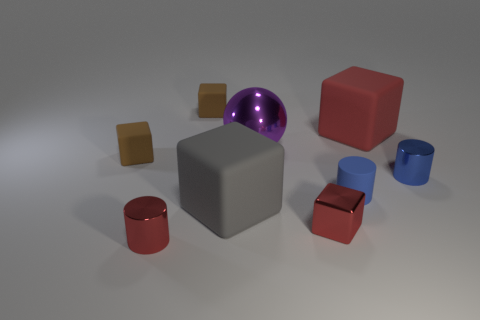How many red things are in front of the big purple thing and behind the tiny red shiny cylinder?
Give a very brief answer. 1. How many objects are either blue cylinders or large rubber cubes left of the matte cylinder?
Give a very brief answer. 3. Are there more purple spheres than small blue cylinders?
Your answer should be very brief. No. What shape is the tiny thing in front of the tiny red cube?
Keep it short and to the point. Cylinder. How many red metal things are the same shape as the blue rubber thing?
Offer a terse response. 1. There is a cube to the left of the tiny shiny object that is left of the gray matte block; how big is it?
Keep it short and to the point. Small. What number of red things are either metallic things or metallic cylinders?
Keep it short and to the point. 2. Are there fewer large gray objects that are in front of the gray object than small blue metallic cylinders behind the small red shiny cylinder?
Your response must be concise. Yes. Do the gray cube and the shiny thing that is behind the small blue metal thing have the same size?
Keep it short and to the point. Yes. How many balls are the same size as the red rubber thing?
Provide a succinct answer. 1. 